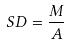<formula> <loc_0><loc_0><loc_500><loc_500>S D = \frac { M } { A }</formula> 